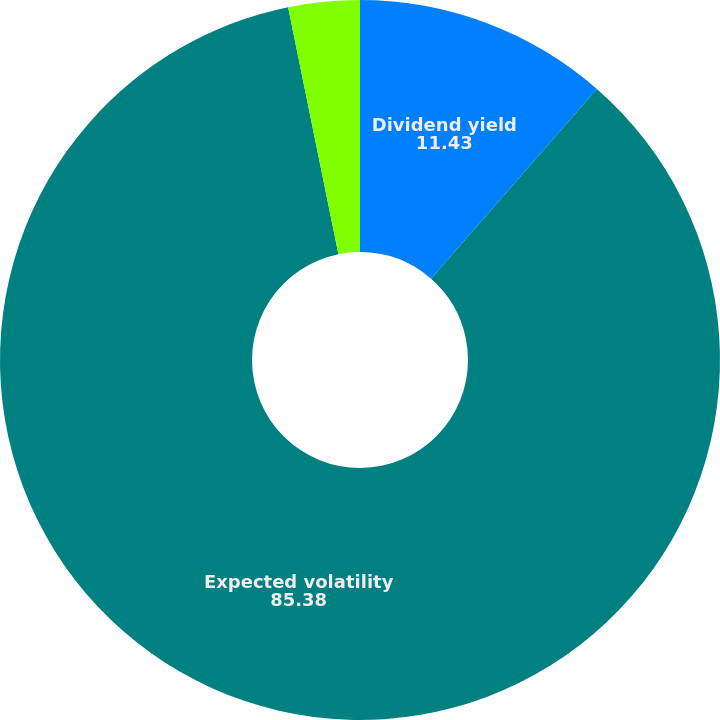Convert chart to OTSL. <chart><loc_0><loc_0><loc_500><loc_500><pie_chart><fcel>Dividend yield<fcel>Expected volatility<fcel>Risk-free interest rate<nl><fcel>11.43%<fcel>85.38%<fcel>3.2%<nl></chart> 